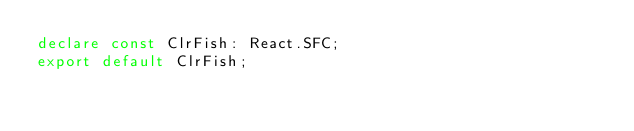Convert code to text. <code><loc_0><loc_0><loc_500><loc_500><_TypeScript_>declare const ClrFish: React.SFC;
export default ClrFish;
</code> 